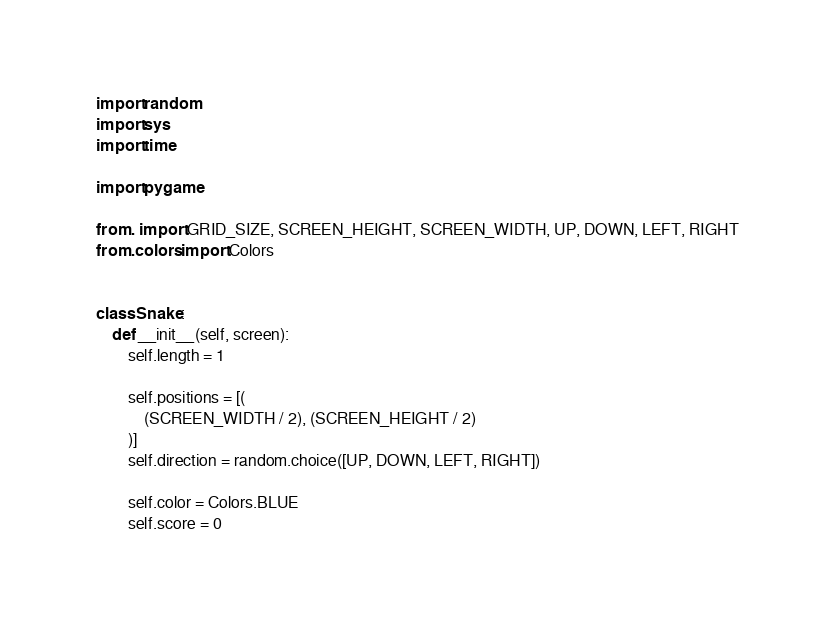<code> <loc_0><loc_0><loc_500><loc_500><_Python_>import random
import sys
import time

import pygame

from . import GRID_SIZE, SCREEN_HEIGHT, SCREEN_WIDTH, UP, DOWN, LEFT, RIGHT
from .colors import Colors


class Snake:
    def __init__(self, screen):
        self.length = 1

        self.positions = [(
            (SCREEN_WIDTH / 2), (SCREEN_HEIGHT / 2)
        )]
        self.direction = random.choice([UP, DOWN, LEFT, RIGHT])

        self.color = Colors.BLUE
        self.score = 0</code> 